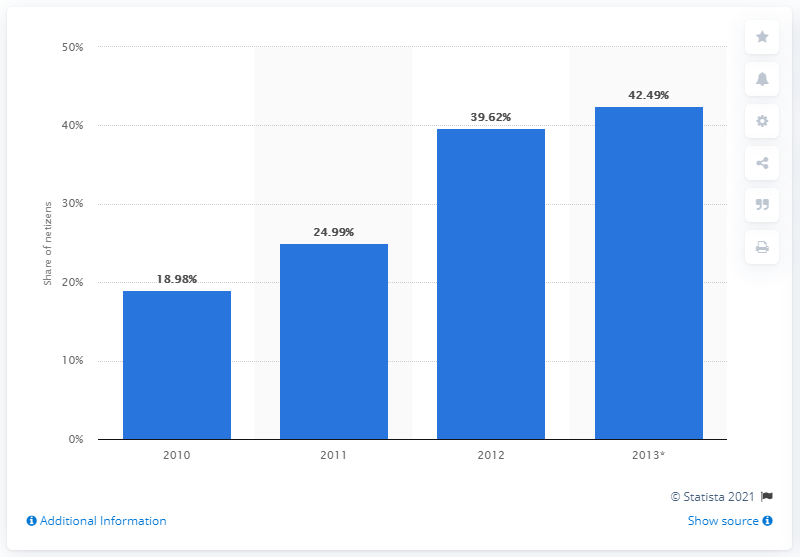Point out several critical features in this image. In 2013, approximately 42.49% of Indonesian internet users spent at least 3 hours per day online. 